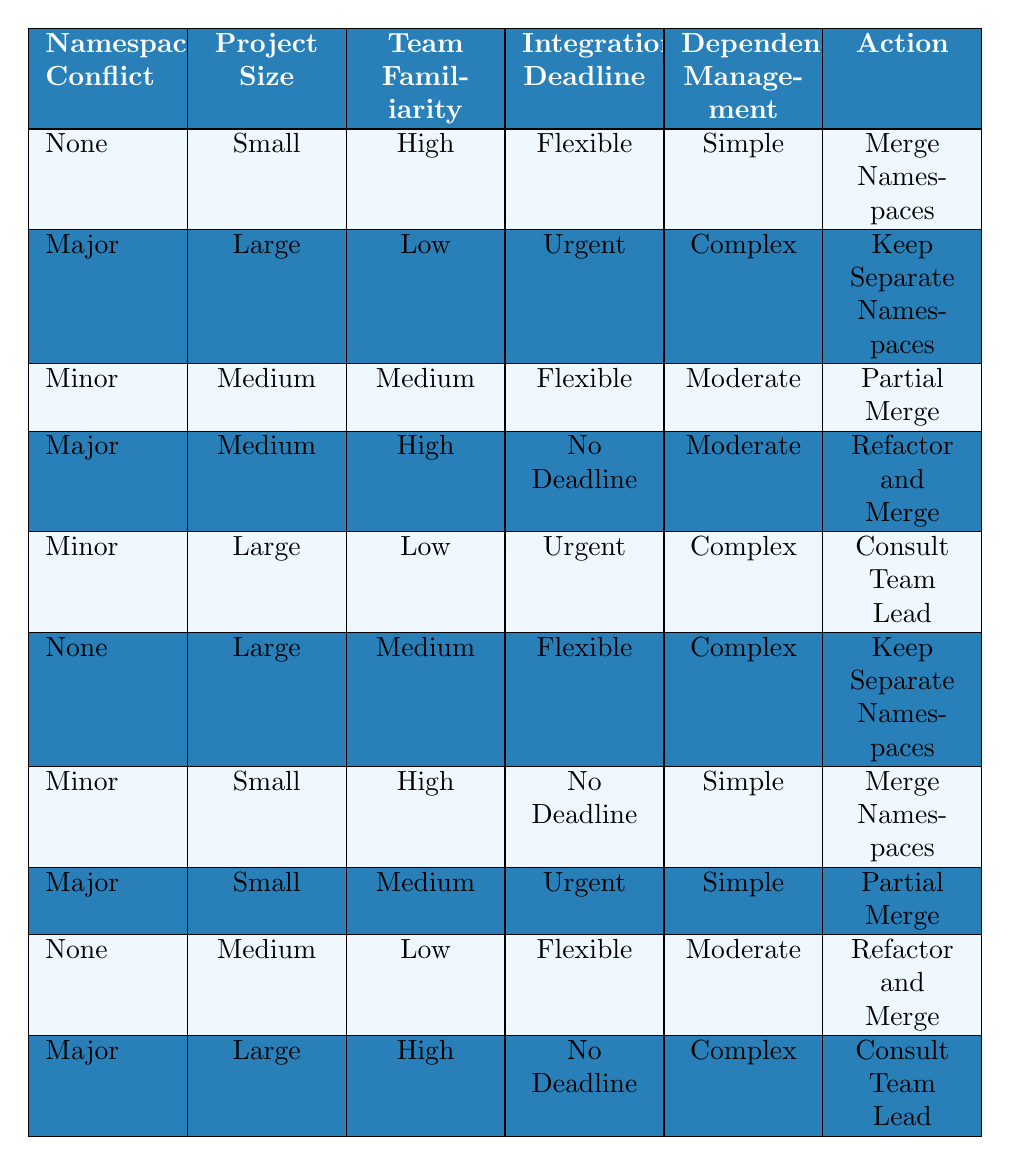What action should be taken if there is a minor namespace conflict, the project is medium-sized, the team has medium familiarity, the deadline is flexible, and dependency management is moderate? According to the table, for the condition of a minor namespace conflict, medium project size, medium team familiarity, flexible deadline, and moderate dependency management, the action specified is "Partial Merge."
Answer: Partial Merge Is the action "Keep Separate Namespaces" associated with a major namespace conflict and a large project? Yes, the table specifies that if there is a major namespace conflict, a large project, low team familiarity, an urgent deadline, and complex dependency management, the action is to "Keep Separate Namespaces."
Answer: Yes What are the two conditions listed for merging namespaces if the team familiarity is high? The table shows two rows with "Merge Namespaces" as the action for high team familiarity: the first is for no namespace conflict, small project size, flexible deadline, and simple dependency management; the second is for minor namespace conflict, small project size, no deadline, and simple dependency management.
Answer: No namespace conflict and minor namespace conflict If a project is small and there's a major namespace conflict with low team familiarity and urgent deadline, what action should be taken? The table indicates that for a small project with a major namespace conflict, low team familiarity, urgent deadline, and simple dependency management, the action recommended is "Partial Merge."
Answer: Partial Merge What is the action needed if the integration deadline is no deadline, and the project is large with major conflict and high team familiarity? The conditions indicate that with a major conflict, large project size, high team familiarity, no deadline, and complex dependency management, the action is to "Consult Team Lead."
Answer: Consult Team Lead If there are four conditions met with a minor conflict, small project, high familiarity, and no deadline, what should be done? Checking the table, it specifies that with a minor namespace conflict, small project size, high team familiarity, no deadline, and simple dependency management, the action should be "Merge Namespaces."
Answer: Merge Namespaces If a large project has none namespace conflict and flexible deadline, can we merge namespaces? Yes, the table confirms that if there is no namespace conflict in a large project, flexible deadline, and complex dependency management, the action states to "Keep Separate Namespaces."
Answer: Yes 